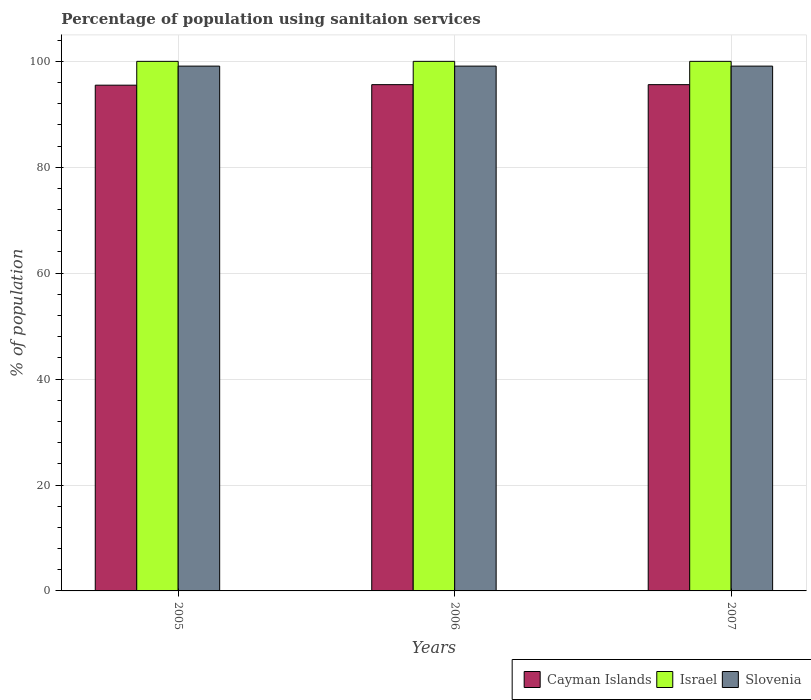Are the number of bars on each tick of the X-axis equal?
Your answer should be very brief. Yes. How many bars are there on the 3rd tick from the left?
Your answer should be compact. 3. How many bars are there on the 1st tick from the right?
Your answer should be very brief. 3. In how many cases, is the number of bars for a given year not equal to the number of legend labels?
Your answer should be very brief. 0. What is the percentage of population using sanitaion services in Israel in 2006?
Provide a succinct answer. 100. Across all years, what is the maximum percentage of population using sanitaion services in Cayman Islands?
Make the answer very short. 95.6. Across all years, what is the minimum percentage of population using sanitaion services in Cayman Islands?
Your response must be concise. 95.5. In which year was the percentage of population using sanitaion services in Israel minimum?
Make the answer very short. 2005. What is the total percentage of population using sanitaion services in Israel in the graph?
Keep it short and to the point. 300. What is the difference between the percentage of population using sanitaion services in Slovenia in 2006 and that in 2007?
Give a very brief answer. 0. What is the difference between the percentage of population using sanitaion services in Cayman Islands in 2007 and the percentage of population using sanitaion services in Israel in 2005?
Provide a short and direct response. -4.4. What is the average percentage of population using sanitaion services in Cayman Islands per year?
Provide a succinct answer. 95.57. In the year 2006, what is the difference between the percentage of population using sanitaion services in Cayman Islands and percentage of population using sanitaion services in Slovenia?
Make the answer very short. -3.5. In how many years, is the percentage of population using sanitaion services in Cayman Islands greater than 68 %?
Keep it short and to the point. 3. Is the percentage of population using sanitaion services in Cayman Islands in 2006 less than that in 2007?
Offer a very short reply. No. What is the difference between the highest and the second highest percentage of population using sanitaion services in Cayman Islands?
Ensure brevity in your answer.  0. What is the difference between the highest and the lowest percentage of population using sanitaion services in Israel?
Your answer should be very brief. 0. Is the sum of the percentage of population using sanitaion services in Israel in 2005 and 2006 greater than the maximum percentage of population using sanitaion services in Slovenia across all years?
Ensure brevity in your answer.  Yes. What does the 3rd bar from the left in 2007 represents?
Offer a terse response. Slovenia. What does the 3rd bar from the right in 2005 represents?
Keep it short and to the point. Cayman Islands. Is it the case that in every year, the sum of the percentage of population using sanitaion services in Israel and percentage of population using sanitaion services in Cayman Islands is greater than the percentage of population using sanitaion services in Slovenia?
Your answer should be very brief. Yes. How many bars are there?
Your answer should be very brief. 9. How many years are there in the graph?
Ensure brevity in your answer.  3. What is the difference between two consecutive major ticks on the Y-axis?
Your response must be concise. 20. Are the values on the major ticks of Y-axis written in scientific E-notation?
Ensure brevity in your answer.  No. Does the graph contain grids?
Ensure brevity in your answer.  Yes. Where does the legend appear in the graph?
Your answer should be compact. Bottom right. How many legend labels are there?
Keep it short and to the point. 3. How are the legend labels stacked?
Your answer should be compact. Horizontal. What is the title of the graph?
Make the answer very short. Percentage of population using sanitaion services. What is the label or title of the Y-axis?
Provide a succinct answer. % of population. What is the % of population of Cayman Islands in 2005?
Your answer should be compact. 95.5. What is the % of population of Slovenia in 2005?
Keep it short and to the point. 99.1. What is the % of population of Cayman Islands in 2006?
Your response must be concise. 95.6. What is the % of population of Slovenia in 2006?
Your answer should be compact. 99.1. What is the % of population of Cayman Islands in 2007?
Ensure brevity in your answer.  95.6. What is the % of population in Israel in 2007?
Keep it short and to the point. 100. What is the % of population in Slovenia in 2007?
Your answer should be compact. 99.1. Across all years, what is the maximum % of population of Cayman Islands?
Offer a very short reply. 95.6. Across all years, what is the maximum % of population of Slovenia?
Offer a terse response. 99.1. Across all years, what is the minimum % of population of Cayman Islands?
Offer a very short reply. 95.5. Across all years, what is the minimum % of population of Slovenia?
Your answer should be compact. 99.1. What is the total % of population of Cayman Islands in the graph?
Your answer should be very brief. 286.7. What is the total % of population in Israel in the graph?
Your answer should be compact. 300. What is the total % of population in Slovenia in the graph?
Make the answer very short. 297.3. What is the difference between the % of population in Israel in 2005 and that in 2006?
Offer a terse response. 0. What is the difference between the % of population in Cayman Islands in 2006 and that in 2007?
Provide a succinct answer. 0. What is the difference between the % of population in Israel in 2006 and that in 2007?
Your response must be concise. 0. What is the difference between the % of population of Cayman Islands in 2005 and the % of population of Israel in 2006?
Give a very brief answer. -4.5. What is the difference between the % of population in Cayman Islands in 2005 and the % of population in Slovenia in 2006?
Make the answer very short. -3.6. What is the difference between the % of population of Israel in 2005 and the % of population of Slovenia in 2006?
Your answer should be very brief. 0.9. What is the average % of population of Cayman Islands per year?
Your answer should be very brief. 95.57. What is the average % of population in Israel per year?
Offer a very short reply. 100. What is the average % of population of Slovenia per year?
Keep it short and to the point. 99.1. In the year 2005, what is the difference between the % of population of Cayman Islands and % of population of Israel?
Ensure brevity in your answer.  -4.5. In the year 2005, what is the difference between the % of population of Cayman Islands and % of population of Slovenia?
Your answer should be compact. -3.6. In the year 2005, what is the difference between the % of population of Israel and % of population of Slovenia?
Ensure brevity in your answer.  0.9. In the year 2006, what is the difference between the % of population of Cayman Islands and % of population of Israel?
Keep it short and to the point. -4.4. In the year 2006, what is the difference between the % of population of Israel and % of population of Slovenia?
Offer a very short reply. 0.9. In the year 2007, what is the difference between the % of population of Israel and % of population of Slovenia?
Give a very brief answer. 0.9. What is the ratio of the % of population of Cayman Islands in 2005 to that in 2006?
Offer a terse response. 1. What is the ratio of the % of population of Cayman Islands in 2005 to that in 2007?
Give a very brief answer. 1. What is the ratio of the % of population of Israel in 2005 to that in 2007?
Provide a succinct answer. 1. What is the ratio of the % of population of Cayman Islands in 2006 to that in 2007?
Offer a very short reply. 1. What is the difference between the highest and the second highest % of population in Cayman Islands?
Ensure brevity in your answer.  0. What is the difference between the highest and the lowest % of population in Cayman Islands?
Provide a short and direct response. 0.1. What is the difference between the highest and the lowest % of population of Israel?
Provide a succinct answer. 0. 